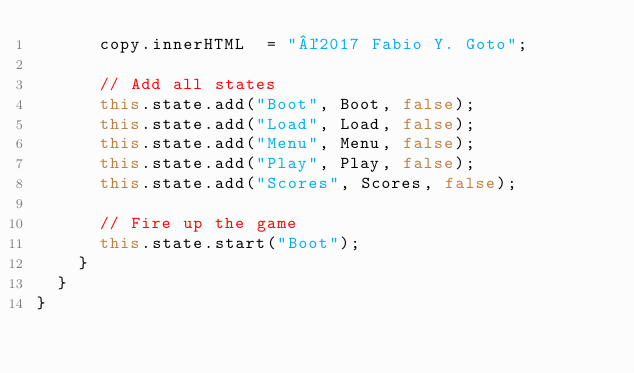<code> <loc_0><loc_0><loc_500><loc_500><_TypeScript_>      copy.innerHTML  = "©2017 Fabio Y. Goto";

      // Add all states
      this.state.add("Boot", Boot, false);
      this.state.add("Load", Load, false);
      this.state.add("Menu", Menu, false);
      this.state.add("Play", Play, false);
      this.state.add("Scores", Scores, false);

      // Fire up the game
      this.state.start("Boot");
    }
  }
}
</code> 